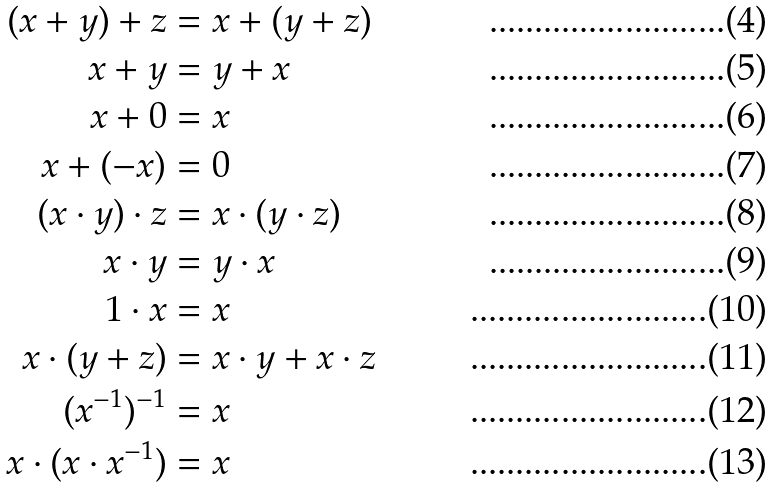<formula> <loc_0><loc_0><loc_500><loc_500>( x + y ) + z & = x + ( y + z ) \\ x + y & = y + x \\ x + 0 & = x \\ x + ( - x ) & = 0 \\ ( x \cdot y ) \cdot z & = x \cdot ( y \cdot z ) \\ x \cdot y & = y \cdot x \\ 1 \cdot x & = x \\ x \cdot ( y + z ) & = x \cdot y + x \cdot z \\ ( x ^ { - 1 } ) ^ { - 1 } & = x \\ x \cdot ( x \cdot x ^ { - 1 } ) & = x</formula> 